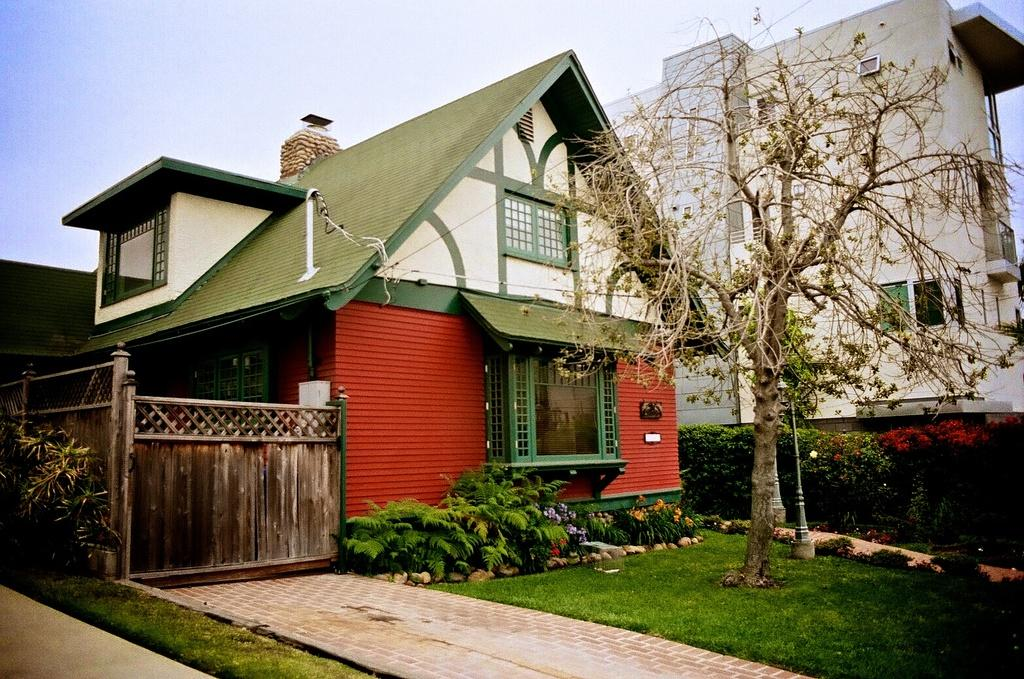What type of vegetation is on the right side of the image? There is a tree on the right side of the image. What structure is located on the left side of the image? There is a wooden gate on the left side of the image. What type of buildings can be seen in the middle of the image? There are houses in the middle of the image. What is visible at the top of the image? The sky is visible at the top of the image. How many snakes are slithering around the wooden gate in the image? There are no snakes present in the image; it features a tree, a wooden gate, houses, and a sky. What type of tool is the carpenter using to fix the houses in the image? There is no carpenter or tool usage depicted in the image; it only shows a tree, a wooden gate, houses, and a sky. 